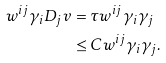Convert formula to latex. <formula><loc_0><loc_0><loc_500><loc_500>w ^ { i j } \gamma _ { i } D _ { j } v & = \tau w ^ { i j } \gamma _ { i } \gamma _ { j } \\ & \leq C w ^ { i j } \gamma _ { i } \gamma _ { j } .</formula> 